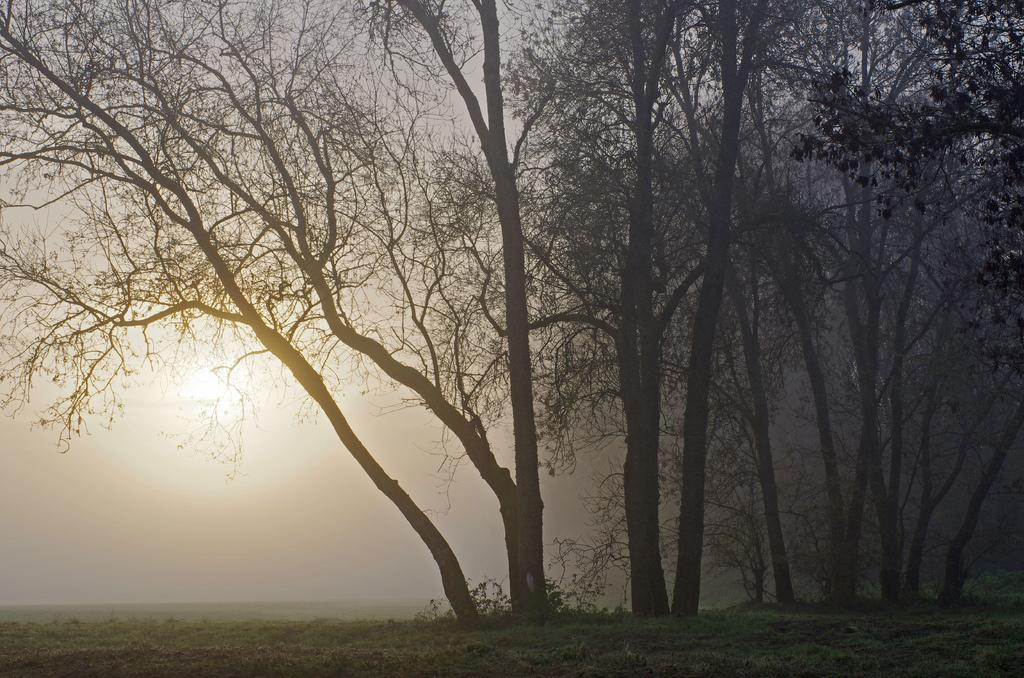What type of surface can be seen in the image? There is ground visible in the image. What is growing on the ground in the image? There is grass on the ground. What type of vegetation is present in the image? There are trees in the image. What is the color of the trees in the image? The trees are black in color. What can be seen in the distance in the image? The sky is visible in the background of the image. What is the weight of the ear in the image? There is no ear present in the image, so it is not possible to determine its weight. 